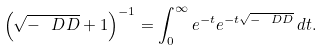Convert formula to latex. <formula><loc_0><loc_0><loc_500><loc_500>\left ( \sqrt { - \ D D } + 1 \right ) ^ { - 1 } = \int _ { 0 } ^ { \infty } e ^ { - t } e ^ { - t \sqrt { - \ D D } } \, d t .</formula> 